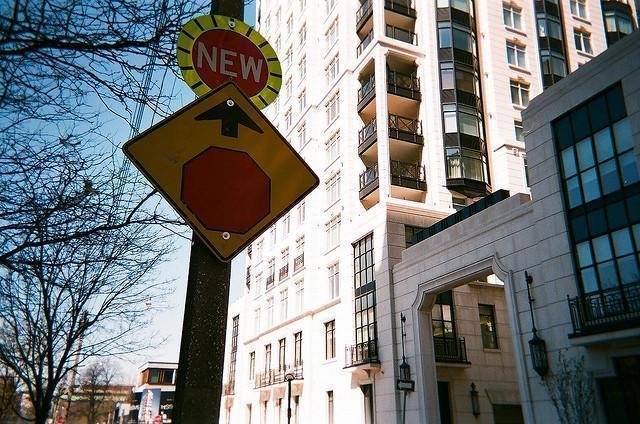The area outside the building would be described as what by a person?
Answer the question by selecting the correct answer among the 4 following choices and explain your choice with a short sentence. The answer should be formatted with the following format: `Answer: choice
Rationale: rationale.`
Options: Mild, warm, hot, cold. Answer: cold.
Rationale: The building casts a shadow. the sun can't shine where there is a shadow. 